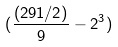<formula> <loc_0><loc_0><loc_500><loc_500>( \frac { ( 2 9 1 / 2 ) } { 9 } - 2 ^ { 3 } )</formula> 